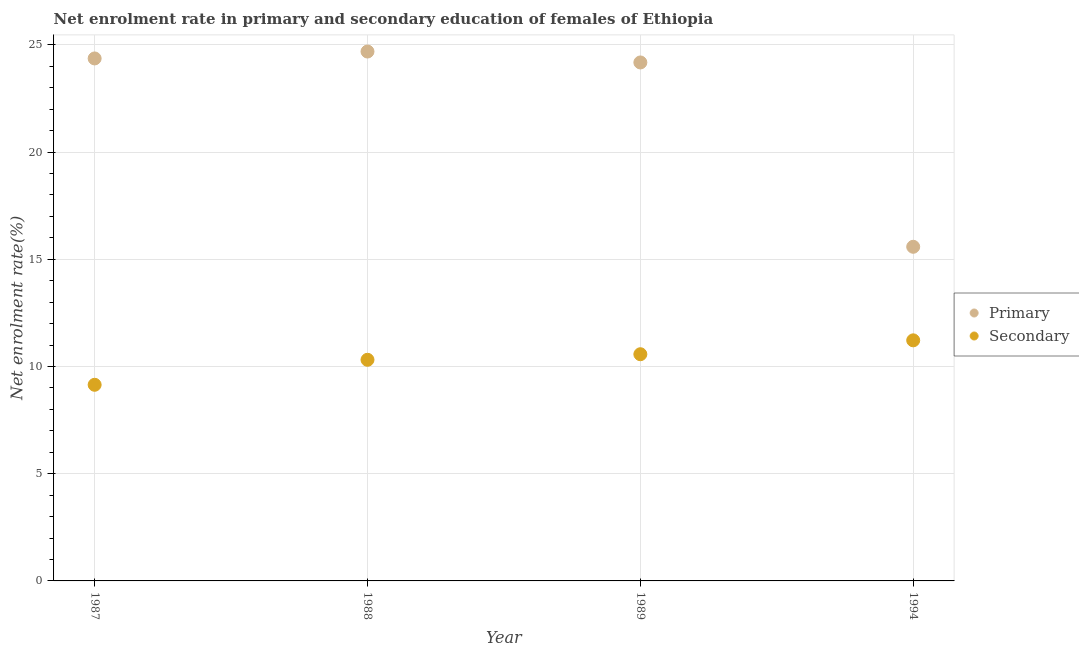How many different coloured dotlines are there?
Make the answer very short. 2. What is the enrollment rate in primary education in 1994?
Your answer should be very brief. 15.58. Across all years, what is the maximum enrollment rate in primary education?
Give a very brief answer. 24.69. Across all years, what is the minimum enrollment rate in primary education?
Make the answer very short. 15.58. In which year was the enrollment rate in primary education minimum?
Offer a terse response. 1994. What is the total enrollment rate in secondary education in the graph?
Give a very brief answer. 41.25. What is the difference between the enrollment rate in secondary education in 1987 and that in 1988?
Your response must be concise. -1.17. What is the difference between the enrollment rate in secondary education in 1989 and the enrollment rate in primary education in 1988?
Give a very brief answer. -14.12. What is the average enrollment rate in secondary education per year?
Make the answer very short. 10.31. In the year 1987, what is the difference between the enrollment rate in primary education and enrollment rate in secondary education?
Offer a very short reply. 15.22. In how many years, is the enrollment rate in secondary education greater than 23 %?
Provide a succinct answer. 0. What is the ratio of the enrollment rate in primary education in 1987 to that in 1994?
Ensure brevity in your answer.  1.56. What is the difference between the highest and the second highest enrollment rate in primary education?
Offer a very short reply. 0.32. What is the difference between the highest and the lowest enrollment rate in secondary education?
Ensure brevity in your answer.  2.07. Is the sum of the enrollment rate in secondary education in 1988 and 1989 greater than the maximum enrollment rate in primary education across all years?
Your answer should be compact. No. Is the enrollment rate in secondary education strictly less than the enrollment rate in primary education over the years?
Make the answer very short. Yes. How many years are there in the graph?
Give a very brief answer. 4. Are the values on the major ticks of Y-axis written in scientific E-notation?
Provide a short and direct response. No. Does the graph contain grids?
Offer a terse response. Yes. Where does the legend appear in the graph?
Provide a short and direct response. Center right. How are the legend labels stacked?
Offer a terse response. Vertical. What is the title of the graph?
Your answer should be compact. Net enrolment rate in primary and secondary education of females of Ethiopia. What is the label or title of the Y-axis?
Keep it short and to the point. Net enrolment rate(%). What is the Net enrolment rate(%) in Primary in 1987?
Offer a very short reply. 24.37. What is the Net enrolment rate(%) of Secondary in 1987?
Your answer should be very brief. 9.15. What is the Net enrolment rate(%) in Primary in 1988?
Offer a terse response. 24.69. What is the Net enrolment rate(%) in Secondary in 1988?
Give a very brief answer. 10.31. What is the Net enrolment rate(%) in Primary in 1989?
Your answer should be very brief. 24.18. What is the Net enrolment rate(%) of Secondary in 1989?
Offer a terse response. 10.57. What is the Net enrolment rate(%) in Primary in 1994?
Offer a terse response. 15.58. What is the Net enrolment rate(%) in Secondary in 1994?
Offer a terse response. 11.22. Across all years, what is the maximum Net enrolment rate(%) in Primary?
Your answer should be compact. 24.69. Across all years, what is the maximum Net enrolment rate(%) in Secondary?
Provide a succinct answer. 11.22. Across all years, what is the minimum Net enrolment rate(%) of Primary?
Provide a short and direct response. 15.58. Across all years, what is the minimum Net enrolment rate(%) of Secondary?
Give a very brief answer. 9.15. What is the total Net enrolment rate(%) in Primary in the graph?
Your answer should be very brief. 88.82. What is the total Net enrolment rate(%) in Secondary in the graph?
Give a very brief answer. 41.25. What is the difference between the Net enrolment rate(%) of Primary in 1987 and that in 1988?
Offer a terse response. -0.32. What is the difference between the Net enrolment rate(%) of Secondary in 1987 and that in 1988?
Provide a short and direct response. -1.17. What is the difference between the Net enrolment rate(%) in Primary in 1987 and that in 1989?
Your answer should be very brief. 0.19. What is the difference between the Net enrolment rate(%) in Secondary in 1987 and that in 1989?
Offer a very short reply. -1.43. What is the difference between the Net enrolment rate(%) of Primary in 1987 and that in 1994?
Provide a short and direct response. 8.78. What is the difference between the Net enrolment rate(%) of Secondary in 1987 and that in 1994?
Your answer should be very brief. -2.07. What is the difference between the Net enrolment rate(%) in Primary in 1988 and that in 1989?
Ensure brevity in your answer.  0.51. What is the difference between the Net enrolment rate(%) in Secondary in 1988 and that in 1989?
Offer a very short reply. -0.26. What is the difference between the Net enrolment rate(%) in Primary in 1988 and that in 1994?
Your answer should be compact. 9.11. What is the difference between the Net enrolment rate(%) in Secondary in 1988 and that in 1994?
Offer a very short reply. -0.91. What is the difference between the Net enrolment rate(%) of Primary in 1989 and that in 1994?
Offer a terse response. 8.6. What is the difference between the Net enrolment rate(%) of Secondary in 1989 and that in 1994?
Give a very brief answer. -0.65. What is the difference between the Net enrolment rate(%) of Primary in 1987 and the Net enrolment rate(%) of Secondary in 1988?
Keep it short and to the point. 14.05. What is the difference between the Net enrolment rate(%) in Primary in 1987 and the Net enrolment rate(%) in Secondary in 1989?
Offer a terse response. 13.79. What is the difference between the Net enrolment rate(%) of Primary in 1987 and the Net enrolment rate(%) of Secondary in 1994?
Keep it short and to the point. 13.15. What is the difference between the Net enrolment rate(%) in Primary in 1988 and the Net enrolment rate(%) in Secondary in 1989?
Keep it short and to the point. 14.12. What is the difference between the Net enrolment rate(%) in Primary in 1988 and the Net enrolment rate(%) in Secondary in 1994?
Make the answer very short. 13.47. What is the difference between the Net enrolment rate(%) in Primary in 1989 and the Net enrolment rate(%) in Secondary in 1994?
Provide a short and direct response. 12.96. What is the average Net enrolment rate(%) in Primary per year?
Your answer should be compact. 22.2. What is the average Net enrolment rate(%) in Secondary per year?
Offer a very short reply. 10.31. In the year 1987, what is the difference between the Net enrolment rate(%) in Primary and Net enrolment rate(%) in Secondary?
Ensure brevity in your answer.  15.22. In the year 1988, what is the difference between the Net enrolment rate(%) of Primary and Net enrolment rate(%) of Secondary?
Ensure brevity in your answer.  14.38. In the year 1989, what is the difference between the Net enrolment rate(%) in Primary and Net enrolment rate(%) in Secondary?
Offer a terse response. 13.61. In the year 1994, what is the difference between the Net enrolment rate(%) in Primary and Net enrolment rate(%) in Secondary?
Give a very brief answer. 4.36. What is the ratio of the Net enrolment rate(%) in Secondary in 1987 to that in 1988?
Offer a terse response. 0.89. What is the ratio of the Net enrolment rate(%) of Primary in 1987 to that in 1989?
Offer a very short reply. 1.01. What is the ratio of the Net enrolment rate(%) in Secondary in 1987 to that in 1989?
Make the answer very short. 0.87. What is the ratio of the Net enrolment rate(%) in Primary in 1987 to that in 1994?
Offer a terse response. 1.56. What is the ratio of the Net enrolment rate(%) in Secondary in 1987 to that in 1994?
Offer a very short reply. 0.82. What is the ratio of the Net enrolment rate(%) in Primary in 1988 to that in 1989?
Give a very brief answer. 1.02. What is the ratio of the Net enrolment rate(%) of Secondary in 1988 to that in 1989?
Ensure brevity in your answer.  0.98. What is the ratio of the Net enrolment rate(%) in Primary in 1988 to that in 1994?
Your response must be concise. 1.58. What is the ratio of the Net enrolment rate(%) in Secondary in 1988 to that in 1994?
Your answer should be very brief. 0.92. What is the ratio of the Net enrolment rate(%) in Primary in 1989 to that in 1994?
Give a very brief answer. 1.55. What is the ratio of the Net enrolment rate(%) in Secondary in 1989 to that in 1994?
Keep it short and to the point. 0.94. What is the difference between the highest and the second highest Net enrolment rate(%) in Primary?
Your answer should be very brief. 0.32. What is the difference between the highest and the second highest Net enrolment rate(%) of Secondary?
Offer a terse response. 0.65. What is the difference between the highest and the lowest Net enrolment rate(%) of Primary?
Make the answer very short. 9.11. What is the difference between the highest and the lowest Net enrolment rate(%) in Secondary?
Give a very brief answer. 2.07. 